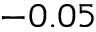Convert formula to latex. <formula><loc_0><loc_0><loc_500><loc_500>- 0 . 0 5</formula> 